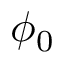Convert formula to latex. <formula><loc_0><loc_0><loc_500><loc_500>\phi _ { 0 }</formula> 